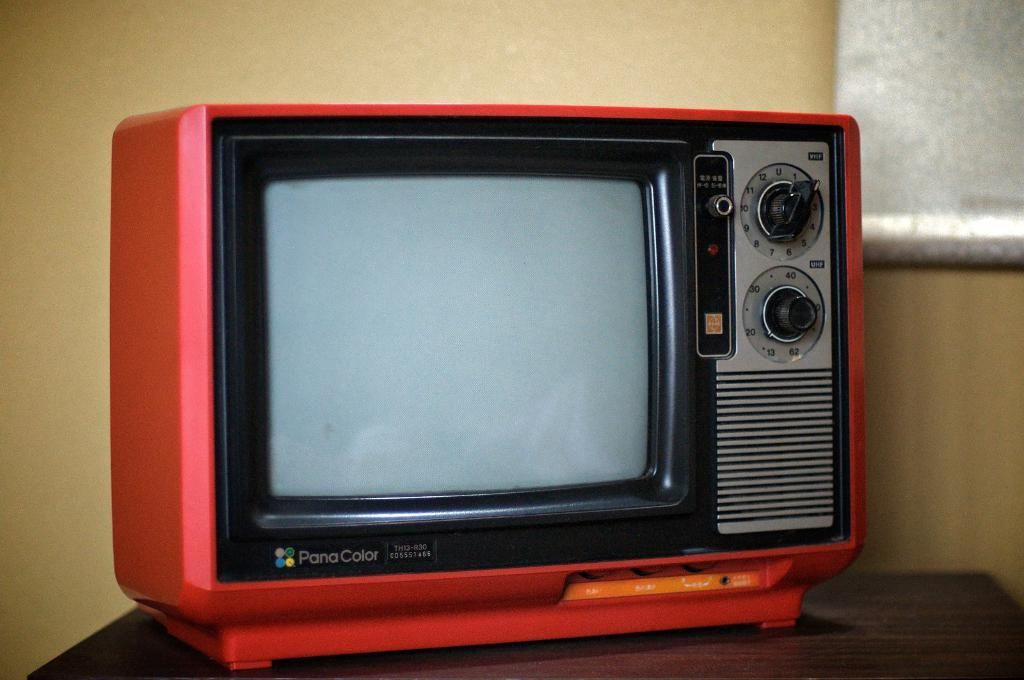<image>
Offer a succinct explanation of the picture presented. An old Pana Coice tv set sits on a table. 